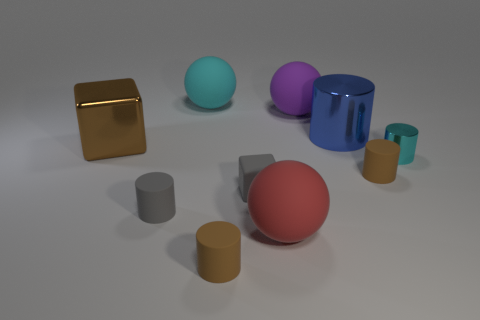Subtract all red spheres. How many spheres are left? 2 Subtract all blue metal cylinders. How many cylinders are left? 4 Add 9 small gray cubes. How many small gray cubes exist? 10 Subtract 0 green balls. How many objects are left? 10 Subtract all cubes. How many objects are left? 8 Subtract 1 blocks. How many blocks are left? 1 Subtract all blue cylinders. Subtract all green blocks. How many cylinders are left? 4 Subtract all yellow cylinders. How many purple spheres are left? 1 Subtract all shiny blocks. Subtract all small things. How many objects are left? 4 Add 4 purple matte things. How many purple matte things are left? 5 